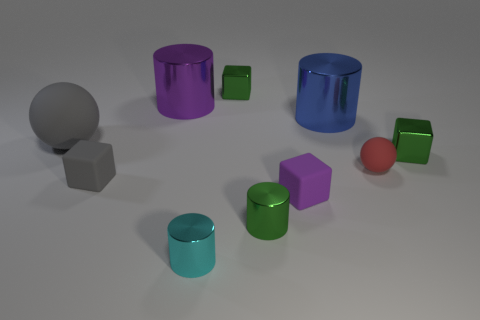Is the large blue cylinder made of the same material as the tiny gray object?
Give a very brief answer. No. Are there more metallic objects behind the cyan metal cylinder than red rubber balls?
Make the answer very short. Yes. What number of big purple things are the same shape as the large blue metal object?
Offer a very short reply. 1. The blue cylinder that is the same material as the purple cylinder is what size?
Give a very brief answer. Large. The matte object that is in front of the big matte object and left of the purple metallic thing is what color?
Give a very brief answer. Gray. How many green metallic cubes have the same size as the red matte sphere?
Offer a terse response. 2. The block that is the same color as the big sphere is what size?
Offer a terse response. Small. What size is the metal cylinder that is both behind the tiny cyan cylinder and in front of the blue metal cylinder?
Make the answer very short. Small. There is a small metallic block that is in front of the tiny green metal object behind the big gray thing; what number of green cubes are behind it?
Offer a very short reply. 1. Are there any matte cubes that have the same color as the large rubber ball?
Ensure brevity in your answer.  Yes. 